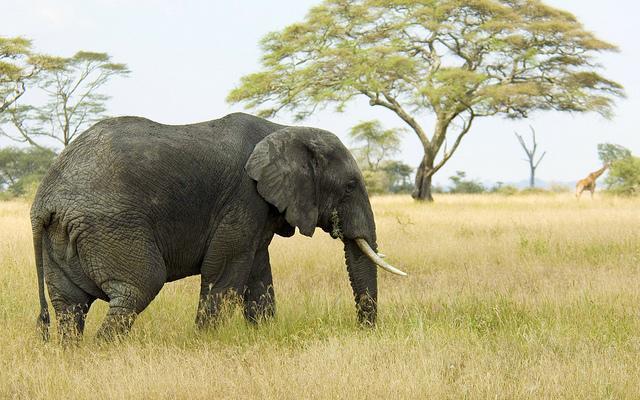How many clocks are in front of the man?
Give a very brief answer. 0. 